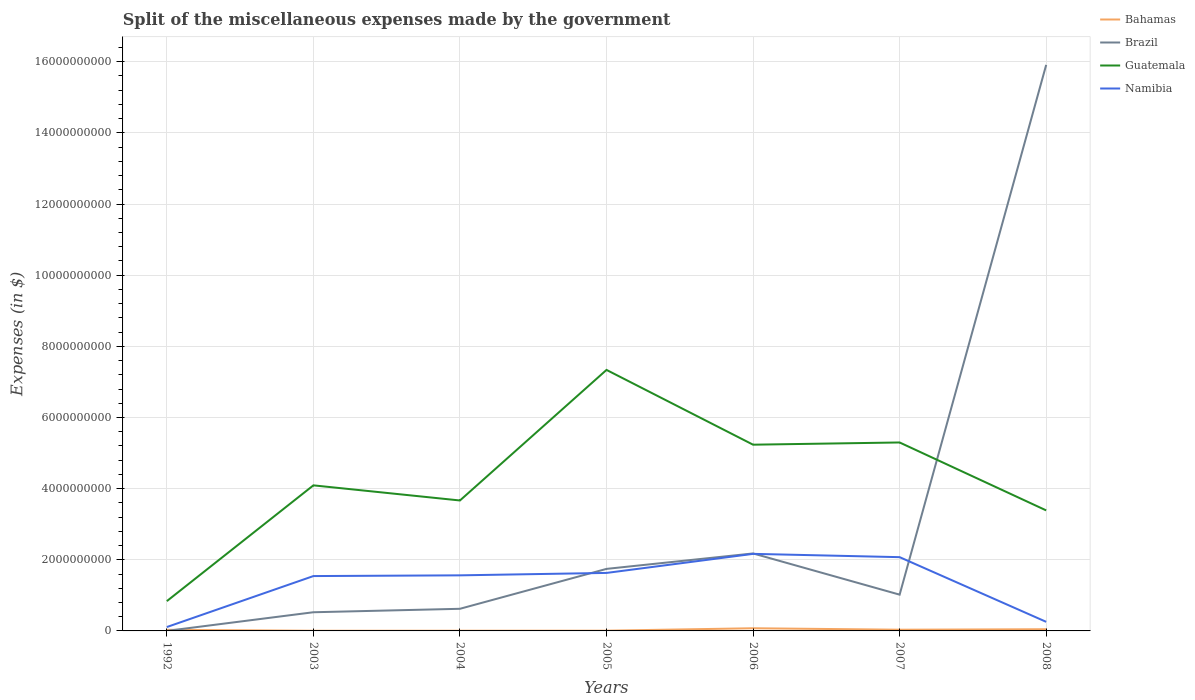How many different coloured lines are there?
Provide a succinct answer. 4. Does the line corresponding to Bahamas intersect with the line corresponding to Namibia?
Offer a terse response. No. Across all years, what is the maximum miscellaneous expenses made by the government in Bahamas?
Make the answer very short. 4.60e+06. In which year was the miscellaneous expenses made by the government in Guatemala maximum?
Your response must be concise. 1992. What is the total miscellaneous expenses made by the government in Bahamas in the graph?
Your answer should be compact. -9.39e+05. What is the difference between the highest and the second highest miscellaneous expenses made by the government in Namibia?
Provide a succinct answer. 2.06e+09. Is the miscellaneous expenses made by the government in Bahamas strictly greater than the miscellaneous expenses made by the government in Brazil over the years?
Provide a short and direct response. No. What is the difference between two consecutive major ticks on the Y-axis?
Make the answer very short. 2.00e+09. Are the values on the major ticks of Y-axis written in scientific E-notation?
Make the answer very short. No. Does the graph contain any zero values?
Make the answer very short. No. Does the graph contain grids?
Ensure brevity in your answer.  Yes. Where does the legend appear in the graph?
Your response must be concise. Top right. How many legend labels are there?
Ensure brevity in your answer.  4. What is the title of the graph?
Offer a very short reply. Split of the miscellaneous expenses made by the government. What is the label or title of the X-axis?
Your response must be concise. Years. What is the label or title of the Y-axis?
Offer a very short reply. Expenses (in $). What is the Expenses (in $) of Bahamas in 1992?
Make the answer very short. 3.16e+07. What is the Expenses (in $) in Brazil in 1992?
Keep it short and to the point. 1.12e+06. What is the Expenses (in $) of Guatemala in 1992?
Your answer should be compact. 8.37e+08. What is the Expenses (in $) in Namibia in 1992?
Offer a very short reply. 1.09e+08. What is the Expenses (in $) of Bahamas in 2003?
Provide a short and direct response. 4.60e+06. What is the Expenses (in $) in Brazil in 2003?
Your answer should be very brief. 5.25e+08. What is the Expenses (in $) in Guatemala in 2003?
Ensure brevity in your answer.  4.09e+09. What is the Expenses (in $) in Namibia in 2003?
Provide a short and direct response. 1.54e+09. What is the Expenses (in $) of Bahamas in 2004?
Ensure brevity in your answer.  5.54e+06. What is the Expenses (in $) in Brazil in 2004?
Provide a succinct answer. 6.22e+08. What is the Expenses (in $) of Guatemala in 2004?
Provide a succinct answer. 3.67e+09. What is the Expenses (in $) of Namibia in 2004?
Offer a terse response. 1.56e+09. What is the Expenses (in $) in Bahamas in 2005?
Your answer should be compact. 7.18e+06. What is the Expenses (in $) in Brazil in 2005?
Keep it short and to the point. 1.74e+09. What is the Expenses (in $) of Guatemala in 2005?
Ensure brevity in your answer.  7.34e+09. What is the Expenses (in $) in Namibia in 2005?
Offer a very short reply. 1.63e+09. What is the Expenses (in $) of Bahamas in 2006?
Ensure brevity in your answer.  7.53e+07. What is the Expenses (in $) of Brazil in 2006?
Offer a very short reply. 2.18e+09. What is the Expenses (in $) in Guatemala in 2006?
Provide a succinct answer. 5.24e+09. What is the Expenses (in $) of Namibia in 2006?
Offer a terse response. 2.17e+09. What is the Expenses (in $) in Bahamas in 2007?
Keep it short and to the point. 3.39e+07. What is the Expenses (in $) in Brazil in 2007?
Ensure brevity in your answer.  1.02e+09. What is the Expenses (in $) in Guatemala in 2007?
Keep it short and to the point. 5.30e+09. What is the Expenses (in $) of Namibia in 2007?
Keep it short and to the point. 2.07e+09. What is the Expenses (in $) of Bahamas in 2008?
Your answer should be very brief. 4.76e+07. What is the Expenses (in $) in Brazil in 2008?
Offer a terse response. 1.59e+1. What is the Expenses (in $) in Guatemala in 2008?
Offer a terse response. 3.39e+09. What is the Expenses (in $) in Namibia in 2008?
Give a very brief answer. 2.55e+08. Across all years, what is the maximum Expenses (in $) in Bahamas?
Your response must be concise. 7.53e+07. Across all years, what is the maximum Expenses (in $) in Brazil?
Your answer should be compact. 1.59e+1. Across all years, what is the maximum Expenses (in $) in Guatemala?
Make the answer very short. 7.34e+09. Across all years, what is the maximum Expenses (in $) in Namibia?
Make the answer very short. 2.17e+09. Across all years, what is the minimum Expenses (in $) of Bahamas?
Provide a succinct answer. 4.60e+06. Across all years, what is the minimum Expenses (in $) of Brazil?
Your answer should be compact. 1.12e+06. Across all years, what is the minimum Expenses (in $) of Guatemala?
Provide a succinct answer. 8.37e+08. Across all years, what is the minimum Expenses (in $) of Namibia?
Ensure brevity in your answer.  1.09e+08. What is the total Expenses (in $) in Bahamas in the graph?
Make the answer very short. 2.06e+08. What is the total Expenses (in $) of Brazil in the graph?
Your response must be concise. 2.20e+1. What is the total Expenses (in $) in Guatemala in the graph?
Give a very brief answer. 2.99e+1. What is the total Expenses (in $) of Namibia in the graph?
Make the answer very short. 9.34e+09. What is the difference between the Expenses (in $) of Bahamas in 1992 and that in 2003?
Give a very brief answer. 2.70e+07. What is the difference between the Expenses (in $) of Brazil in 1992 and that in 2003?
Make the answer very short. -5.24e+08. What is the difference between the Expenses (in $) of Guatemala in 1992 and that in 2003?
Offer a terse response. -3.25e+09. What is the difference between the Expenses (in $) of Namibia in 1992 and that in 2003?
Keep it short and to the point. -1.43e+09. What is the difference between the Expenses (in $) of Bahamas in 1992 and that in 2004?
Your response must be concise. 2.61e+07. What is the difference between the Expenses (in $) in Brazil in 1992 and that in 2004?
Keep it short and to the point. -6.21e+08. What is the difference between the Expenses (in $) in Guatemala in 1992 and that in 2004?
Provide a succinct answer. -2.83e+09. What is the difference between the Expenses (in $) in Namibia in 1992 and that in 2004?
Provide a succinct answer. -1.45e+09. What is the difference between the Expenses (in $) in Bahamas in 1992 and that in 2005?
Make the answer very short. 2.44e+07. What is the difference between the Expenses (in $) of Brazil in 1992 and that in 2005?
Provide a succinct answer. -1.74e+09. What is the difference between the Expenses (in $) of Guatemala in 1992 and that in 2005?
Offer a terse response. -6.50e+09. What is the difference between the Expenses (in $) of Namibia in 1992 and that in 2005?
Your answer should be very brief. -1.52e+09. What is the difference between the Expenses (in $) of Bahamas in 1992 and that in 2006?
Make the answer very short. -4.37e+07. What is the difference between the Expenses (in $) in Brazil in 1992 and that in 2006?
Your answer should be very brief. -2.18e+09. What is the difference between the Expenses (in $) of Guatemala in 1992 and that in 2006?
Offer a very short reply. -4.40e+09. What is the difference between the Expenses (in $) in Namibia in 1992 and that in 2006?
Make the answer very short. -2.06e+09. What is the difference between the Expenses (in $) of Bahamas in 1992 and that in 2007?
Make the answer very short. -2.30e+06. What is the difference between the Expenses (in $) of Brazil in 1992 and that in 2007?
Offer a very short reply. -1.02e+09. What is the difference between the Expenses (in $) in Guatemala in 1992 and that in 2007?
Ensure brevity in your answer.  -4.46e+09. What is the difference between the Expenses (in $) in Namibia in 1992 and that in 2007?
Give a very brief answer. -1.96e+09. What is the difference between the Expenses (in $) in Bahamas in 1992 and that in 2008?
Keep it short and to the point. -1.60e+07. What is the difference between the Expenses (in $) of Brazil in 1992 and that in 2008?
Offer a very short reply. -1.59e+1. What is the difference between the Expenses (in $) of Guatemala in 1992 and that in 2008?
Ensure brevity in your answer.  -2.55e+09. What is the difference between the Expenses (in $) in Namibia in 1992 and that in 2008?
Offer a terse response. -1.46e+08. What is the difference between the Expenses (in $) of Bahamas in 2003 and that in 2004?
Your answer should be compact. -9.39e+05. What is the difference between the Expenses (in $) in Brazil in 2003 and that in 2004?
Offer a terse response. -9.71e+07. What is the difference between the Expenses (in $) in Guatemala in 2003 and that in 2004?
Provide a short and direct response. 4.25e+08. What is the difference between the Expenses (in $) in Namibia in 2003 and that in 2004?
Your answer should be very brief. -2.04e+07. What is the difference between the Expenses (in $) in Bahamas in 2003 and that in 2005?
Make the answer very short. -2.58e+06. What is the difference between the Expenses (in $) in Brazil in 2003 and that in 2005?
Your response must be concise. -1.22e+09. What is the difference between the Expenses (in $) in Guatemala in 2003 and that in 2005?
Provide a succinct answer. -3.24e+09. What is the difference between the Expenses (in $) of Namibia in 2003 and that in 2005?
Your answer should be compact. -8.84e+07. What is the difference between the Expenses (in $) of Bahamas in 2003 and that in 2006?
Ensure brevity in your answer.  -7.07e+07. What is the difference between the Expenses (in $) of Brazil in 2003 and that in 2006?
Offer a very short reply. -1.65e+09. What is the difference between the Expenses (in $) in Guatemala in 2003 and that in 2006?
Give a very brief answer. -1.14e+09. What is the difference between the Expenses (in $) of Namibia in 2003 and that in 2006?
Provide a short and direct response. -6.24e+08. What is the difference between the Expenses (in $) in Bahamas in 2003 and that in 2007?
Keep it short and to the point. -2.93e+07. What is the difference between the Expenses (in $) in Brazil in 2003 and that in 2007?
Give a very brief answer. -4.94e+08. What is the difference between the Expenses (in $) in Guatemala in 2003 and that in 2007?
Give a very brief answer. -1.21e+09. What is the difference between the Expenses (in $) of Namibia in 2003 and that in 2007?
Provide a succinct answer. -5.32e+08. What is the difference between the Expenses (in $) of Bahamas in 2003 and that in 2008?
Keep it short and to the point. -4.30e+07. What is the difference between the Expenses (in $) in Brazil in 2003 and that in 2008?
Offer a very short reply. -1.54e+1. What is the difference between the Expenses (in $) in Guatemala in 2003 and that in 2008?
Provide a succinct answer. 7.04e+08. What is the difference between the Expenses (in $) of Namibia in 2003 and that in 2008?
Your answer should be very brief. 1.29e+09. What is the difference between the Expenses (in $) of Bahamas in 2004 and that in 2005?
Your response must be concise. -1.64e+06. What is the difference between the Expenses (in $) of Brazil in 2004 and that in 2005?
Give a very brief answer. -1.12e+09. What is the difference between the Expenses (in $) in Guatemala in 2004 and that in 2005?
Provide a succinct answer. -3.67e+09. What is the difference between the Expenses (in $) of Namibia in 2004 and that in 2005?
Make the answer very short. -6.80e+07. What is the difference between the Expenses (in $) in Bahamas in 2004 and that in 2006?
Offer a very short reply. -6.98e+07. What is the difference between the Expenses (in $) in Brazil in 2004 and that in 2006?
Your answer should be compact. -1.56e+09. What is the difference between the Expenses (in $) of Guatemala in 2004 and that in 2006?
Keep it short and to the point. -1.57e+09. What is the difference between the Expenses (in $) of Namibia in 2004 and that in 2006?
Your answer should be very brief. -6.04e+08. What is the difference between the Expenses (in $) in Bahamas in 2004 and that in 2007?
Ensure brevity in your answer.  -2.84e+07. What is the difference between the Expenses (in $) in Brazil in 2004 and that in 2007?
Provide a succinct answer. -3.97e+08. What is the difference between the Expenses (in $) in Guatemala in 2004 and that in 2007?
Give a very brief answer. -1.63e+09. What is the difference between the Expenses (in $) of Namibia in 2004 and that in 2007?
Provide a short and direct response. -5.11e+08. What is the difference between the Expenses (in $) in Bahamas in 2004 and that in 2008?
Make the answer very short. -4.21e+07. What is the difference between the Expenses (in $) in Brazil in 2004 and that in 2008?
Offer a terse response. -1.53e+1. What is the difference between the Expenses (in $) of Guatemala in 2004 and that in 2008?
Provide a succinct answer. 2.79e+08. What is the difference between the Expenses (in $) in Namibia in 2004 and that in 2008?
Give a very brief answer. 1.31e+09. What is the difference between the Expenses (in $) of Bahamas in 2005 and that in 2006?
Your answer should be very brief. -6.81e+07. What is the difference between the Expenses (in $) of Brazil in 2005 and that in 2006?
Give a very brief answer. -4.34e+08. What is the difference between the Expenses (in $) in Guatemala in 2005 and that in 2006?
Provide a succinct answer. 2.10e+09. What is the difference between the Expenses (in $) of Namibia in 2005 and that in 2006?
Your answer should be compact. -5.36e+08. What is the difference between the Expenses (in $) of Bahamas in 2005 and that in 2007?
Provide a succinct answer. -2.67e+07. What is the difference between the Expenses (in $) of Brazil in 2005 and that in 2007?
Offer a terse response. 7.24e+08. What is the difference between the Expenses (in $) of Guatemala in 2005 and that in 2007?
Keep it short and to the point. 2.04e+09. What is the difference between the Expenses (in $) in Namibia in 2005 and that in 2007?
Ensure brevity in your answer.  -4.43e+08. What is the difference between the Expenses (in $) in Bahamas in 2005 and that in 2008?
Offer a terse response. -4.04e+07. What is the difference between the Expenses (in $) in Brazil in 2005 and that in 2008?
Ensure brevity in your answer.  -1.42e+1. What is the difference between the Expenses (in $) in Guatemala in 2005 and that in 2008?
Give a very brief answer. 3.95e+09. What is the difference between the Expenses (in $) of Namibia in 2005 and that in 2008?
Offer a terse response. 1.37e+09. What is the difference between the Expenses (in $) in Bahamas in 2006 and that in 2007?
Ensure brevity in your answer.  4.14e+07. What is the difference between the Expenses (in $) of Brazil in 2006 and that in 2007?
Keep it short and to the point. 1.16e+09. What is the difference between the Expenses (in $) in Guatemala in 2006 and that in 2007?
Offer a terse response. -6.21e+07. What is the difference between the Expenses (in $) in Namibia in 2006 and that in 2007?
Your answer should be very brief. 9.26e+07. What is the difference between the Expenses (in $) in Bahamas in 2006 and that in 2008?
Provide a succinct answer. 2.77e+07. What is the difference between the Expenses (in $) in Brazil in 2006 and that in 2008?
Your answer should be very brief. -1.37e+1. What is the difference between the Expenses (in $) in Guatemala in 2006 and that in 2008?
Offer a terse response. 1.85e+09. What is the difference between the Expenses (in $) in Namibia in 2006 and that in 2008?
Make the answer very short. 1.91e+09. What is the difference between the Expenses (in $) of Bahamas in 2007 and that in 2008?
Make the answer very short. -1.37e+07. What is the difference between the Expenses (in $) of Brazil in 2007 and that in 2008?
Keep it short and to the point. -1.49e+1. What is the difference between the Expenses (in $) in Guatemala in 2007 and that in 2008?
Offer a very short reply. 1.91e+09. What is the difference between the Expenses (in $) in Namibia in 2007 and that in 2008?
Your answer should be very brief. 1.82e+09. What is the difference between the Expenses (in $) of Bahamas in 1992 and the Expenses (in $) of Brazil in 2003?
Offer a terse response. -4.93e+08. What is the difference between the Expenses (in $) of Bahamas in 1992 and the Expenses (in $) of Guatemala in 2003?
Your answer should be compact. -4.06e+09. What is the difference between the Expenses (in $) of Bahamas in 1992 and the Expenses (in $) of Namibia in 2003?
Provide a short and direct response. -1.51e+09. What is the difference between the Expenses (in $) in Brazil in 1992 and the Expenses (in $) in Guatemala in 2003?
Make the answer very short. -4.09e+09. What is the difference between the Expenses (in $) of Brazil in 1992 and the Expenses (in $) of Namibia in 2003?
Keep it short and to the point. -1.54e+09. What is the difference between the Expenses (in $) of Guatemala in 1992 and the Expenses (in $) of Namibia in 2003?
Provide a succinct answer. -7.05e+08. What is the difference between the Expenses (in $) of Bahamas in 1992 and the Expenses (in $) of Brazil in 2004?
Make the answer very short. -5.90e+08. What is the difference between the Expenses (in $) of Bahamas in 1992 and the Expenses (in $) of Guatemala in 2004?
Give a very brief answer. -3.64e+09. What is the difference between the Expenses (in $) in Bahamas in 1992 and the Expenses (in $) in Namibia in 2004?
Make the answer very short. -1.53e+09. What is the difference between the Expenses (in $) of Brazil in 1992 and the Expenses (in $) of Guatemala in 2004?
Offer a terse response. -3.67e+09. What is the difference between the Expenses (in $) in Brazil in 1992 and the Expenses (in $) in Namibia in 2004?
Offer a very short reply. -1.56e+09. What is the difference between the Expenses (in $) of Guatemala in 1992 and the Expenses (in $) of Namibia in 2004?
Your response must be concise. -7.25e+08. What is the difference between the Expenses (in $) in Bahamas in 1992 and the Expenses (in $) in Brazil in 2005?
Your response must be concise. -1.71e+09. What is the difference between the Expenses (in $) of Bahamas in 1992 and the Expenses (in $) of Guatemala in 2005?
Provide a short and direct response. -7.31e+09. What is the difference between the Expenses (in $) of Bahamas in 1992 and the Expenses (in $) of Namibia in 2005?
Offer a terse response. -1.60e+09. What is the difference between the Expenses (in $) of Brazil in 1992 and the Expenses (in $) of Guatemala in 2005?
Your response must be concise. -7.34e+09. What is the difference between the Expenses (in $) of Brazil in 1992 and the Expenses (in $) of Namibia in 2005?
Provide a short and direct response. -1.63e+09. What is the difference between the Expenses (in $) of Guatemala in 1992 and the Expenses (in $) of Namibia in 2005?
Provide a succinct answer. -7.93e+08. What is the difference between the Expenses (in $) in Bahamas in 1992 and the Expenses (in $) in Brazil in 2006?
Offer a terse response. -2.15e+09. What is the difference between the Expenses (in $) of Bahamas in 1992 and the Expenses (in $) of Guatemala in 2006?
Offer a very short reply. -5.20e+09. What is the difference between the Expenses (in $) in Bahamas in 1992 and the Expenses (in $) in Namibia in 2006?
Make the answer very short. -2.13e+09. What is the difference between the Expenses (in $) of Brazil in 1992 and the Expenses (in $) of Guatemala in 2006?
Your answer should be compact. -5.23e+09. What is the difference between the Expenses (in $) in Brazil in 1992 and the Expenses (in $) in Namibia in 2006?
Your answer should be compact. -2.16e+09. What is the difference between the Expenses (in $) in Guatemala in 1992 and the Expenses (in $) in Namibia in 2006?
Make the answer very short. -1.33e+09. What is the difference between the Expenses (in $) in Bahamas in 1992 and the Expenses (in $) in Brazil in 2007?
Your response must be concise. -9.88e+08. What is the difference between the Expenses (in $) of Bahamas in 1992 and the Expenses (in $) of Guatemala in 2007?
Make the answer very short. -5.27e+09. What is the difference between the Expenses (in $) of Bahamas in 1992 and the Expenses (in $) of Namibia in 2007?
Your answer should be compact. -2.04e+09. What is the difference between the Expenses (in $) in Brazil in 1992 and the Expenses (in $) in Guatemala in 2007?
Keep it short and to the point. -5.30e+09. What is the difference between the Expenses (in $) of Brazil in 1992 and the Expenses (in $) of Namibia in 2007?
Offer a terse response. -2.07e+09. What is the difference between the Expenses (in $) in Guatemala in 1992 and the Expenses (in $) in Namibia in 2007?
Make the answer very short. -1.24e+09. What is the difference between the Expenses (in $) of Bahamas in 1992 and the Expenses (in $) of Brazil in 2008?
Ensure brevity in your answer.  -1.59e+1. What is the difference between the Expenses (in $) of Bahamas in 1992 and the Expenses (in $) of Guatemala in 2008?
Your answer should be compact. -3.36e+09. What is the difference between the Expenses (in $) of Bahamas in 1992 and the Expenses (in $) of Namibia in 2008?
Your response must be concise. -2.24e+08. What is the difference between the Expenses (in $) in Brazil in 1992 and the Expenses (in $) in Guatemala in 2008?
Offer a terse response. -3.39e+09. What is the difference between the Expenses (in $) of Brazil in 1992 and the Expenses (in $) of Namibia in 2008?
Your answer should be very brief. -2.54e+08. What is the difference between the Expenses (in $) of Guatemala in 1992 and the Expenses (in $) of Namibia in 2008?
Your response must be concise. 5.82e+08. What is the difference between the Expenses (in $) of Bahamas in 2003 and the Expenses (in $) of Brazil in 2004?
Provide a succinct answer. -6.17e+08. What is the difference between the Expenses (in $) of Bahamas in 2003 and the Expenses (in $) of Guatemala in 2004?
Give a very brief answer. -3.66e+09. What is the difference between the Expenses (in $) in Bahamas in 2003 and the Expenses (in $) in Namibia in 2004?
Keep it short and to the point. -1.56e+09. What is the difference between the Expenses (in $) in Brazil in 2003 and the Expenses (in $) in Guatemala in 2004?
Give a very brief answer. -3.14e+09. What is the difference between the Expenses (in $) of Brazil in 2003 and the Expenses (in $) of Namibia in 2004?
Offer a terse response. -1.04e+09. What is the difference between the Expenses (in $) of Guatemala in 2003 and the Expenses (in $) of Namibia in 2004?
Provide a succinct answer. 2.53e+09. What is the difference between the Expenses (in $) in Bahamas in 2003 and the Expenses (in $) in Brazil in 2005?
Your answer should be compact. -1.74e+09. What is the difference between the Expenses (in $) of Bahamas in 2003 and the Expenses (in $) of Guatemala in 2005?
Keep it short and to the point. -7.33e+09. What is the difference between the Expenses (in $) of Bahamas in 2003 and the Expenses (in $) of Namibia in 2005?
Keep it short and to the point. -1.63e+09. What is the difference between the Expenses (in $) in Brazil in 2003 and the Expenses (in $) in Guatemala in 2005?
Your answer should be very brief. -6.81e+09. What is the difference between the Expenses (in $) of Brazil in 2003 and the Expenses (in $) of Namibia in 2005?
Your answer should be compact. -1.11e+09. What is the difference between the Expenses (in $) in Guatemala in 2003 and the Expenses (in $) in Namibia in 2005?
Give a very brief answer. 2.46e+09. What is the difference between the Expenses (in $) of Bahamas in 2003 and the Expenses (in $) of Brazil in 2006?
Make the answer very short. -2.17e+09. What is the difference between the Expenses (in $) in Bahamas in 2003 and the Expenses (in $) in Guatemala in 2006?
Make the answer very short. -5.23e+09. What is the difference between the Expenses (in $) of Bahamas in 2003 and the Expenses (in $) of Namibia in 2006?
Offer a terse response. -2.16e+09. What is the difference between the Expenses (in $) of Brazil in 2003 and the Expenses (in $) of Guatemala in 2006?
Offer a very short reply. -4.71e+09. What is the difference between the Expenses (in $) in Brazil in 2003 and the Expenses (in $) in Namibia in 2006?
Keep it short and to the point. -1.64e+09. What is the difference between the Expenses (in $) of Guatemala in 2003 and the Expenses (in $) of Namibia in 2006?
Your answer should be very brief. 1.93e+09. What is the difference between the Expenses (in $) in Bahamas in 2003 and the Expenses (in $) in Brazil in 2007?
Ensure brevity in your answer.  -1.01e+09. What is the difference between the Expenses (in $) in Bahamas in 2003 and the Expenses (in $) in Guatemala in 2007?
Keep it short and to the point. -5.29e+09. What is the difference between the Expenses (in $) of Bahamas in 2003 and the Expenses (in $) of Namibia in 2007?
Give a very brief answer. -2.07e+09. What is the difference between the Expenses (in $) in Brazil in 2003 and the Expenses (in $) in Guatemala in 2007?
Provide a short and direct response. -4.77e+09. What is the difference between the Expenses (in $) in Brazil in 2003 and the Expenses (in $) in Namibia in 2007?
Offer a very short reply. -1.55e+09. What is the difference between the Expenses (in $) of Guatemala in 2003 and the Expenses (in $) of Namibia in 2007?
Offer a very short reply. 2.02e+09. What is the difference between the Expenses (in $) of Bahamas in 2003 and the Expenses (in $) of Brazil in 2008?
Offer a very short reply. -1.59e+1. What is the difference between the Expenses (in $) in Bahamas in 2003 and the Expenses (in $) in Guatemala in 2008?
Your response must be concise. -3.38e+09. What is the difference between the Expenses (in $) in Bahamas in 2003 and the Expenses (in $) in Namibia in 2008?
Give a very brief answer. -2.51e+08. What is the difference between the Expenses (in $) of Brazil in 2003 and the Expenses (in $) of Guatemala in 2008?
Your answer should be compact. -2.86e+09. What is the difference between the Expenses (in $) of Brazil in 2003 and the Expenses (in $) of Namibia in 2008?
Offer a very short reply. 2.70e+08. What is the difference between the Expenses (in $) in Guatemala in 2003 and the Expenses (in $) in Namibia in 2008?
Offer a very short reply. 3.84e+09. What is the difference between the Expenses (in $) of Bahamas in 2004 and the Expenses (in $) of Brazil in 2005?
Offer a terse response. -1.74e+09. What is the difference between the Expenses (in $) in Bahamas in 2004 and the Expenses (in $) in Guatemala in 2005?
Provide a succinct answer. -7.33e+09. What is the difference between the Expenses (in $) in Bahamas in 2004 and the Expenses (in $) in Namibia in 2005?
Give a very brief answer. -1.62e+09. What is the difference between the Expenses (in $) of Brazil in 2004 and the Expenses (in $) of Guatemala in 2005?
Offer a very short reply. -6.71e+09. What is the difference between the Expenses (in $) in Brazil in 2004 and the Expenses (in $) in Namibia in 2005?
Offer a terse response. -1.01e+09. What is the difference between the Expenses (in $) in Guatemala in 2004 and the Expenses (in $) in Namibia in 2005?
Your answer should be compact. 2.04e+09. What is the difference between the Expenses (in $) of Bahamas in 2004 and the Expenses (in $) of Brazil in 2006?
Offer a very short reply. -2.17e+09. What is the difference between the Expenses (in $) in Bahamas in 2004 and the Expenses (in $) in Guatemala in 2006?
Offer a terse response. -5.23e+09. What is the difference between the Expenses (in $) in Bahamas in 2004 and the Expenses (in $) in Namibia in 2006?
Keep it short and to the point. -2.16e+09. What is the difference between the Expenses (in $) in Brazil in 2004 and the Expenses (in $) in Guatemala in 2006?
Provide a short and direct response. -4.61e+09. What is the difference between the Expenses (in $) of Brazil in 2004 and the Expenses (in $) of Namibia in 2006?
Give a very brief answer. -1.54e+09. What is the difference between the Expenses (in $) in Guatemala in 2004 and the Expenses (in $) in Namibia in 2006?
Provide a succinct answer. 1.50e+09. What is the difference between the Expenses (in $) of Bahamas in 2004 and the Expenses (in $) of Brazil in 2007?
Make the answer very short. -1.01e+09. What is the difference between the Expenses (in $) in Bahamas in 2004 and the Expenses (in $) in Guatemala in 2007?
Your answer should be very brief. -5.29e+09. What is the difference between the Expenses (in $) of Bahamas in 2004 and the Expenses (in $) of Namibia in 2007?
Your response must be concise. -2.07e+09. What is the difference between the Expenses (in $) in Brazil in 2004 and the Expenses (in $) in Guatemala in 2007?
Keep it short and to the point. -4.68e+09. What is the difference between the Expenses (in $) of Brazil in 2004 and the Expenses (in $) of Namibia in 2007?
Give a very brief answer. -1.45e+09. What is the difference between the Expenses (in $) of Guatemala in 2004 and the Expenses (in $) of Namibia in 2007?
Your answer should be compact. 1.59e+09. What is the difference between the Expenses (in $) in Bahamas in 2004 and the Expenses (in $) in Brazil in 2008?
Provide a short and direct response. -1.59e+1. What is the difference between the Expenses (in $) of Bahamas in 2004 and the Expenses (in $) of Guatemala in 2008?
Your response must be concise. -3.38e+09. What is the difference between the Expenses (in $) of Bahamas in 2004 and the Expenses (in $) of Namibia in 2008?
Keep it short and to the point. -2.50e+08. What is the difference between the Expenses (in $) of Brazil in 2004 and the Expenses (in $) of Guatemala in 2008?
Your answer should be compact. -2.77e+09. What is the difference between the Expenses (in $) of Brazil in 2004 and the Expenses (in $) of Namibia in 2008?
Your answer should be compact. 3.67e+08. What is the difference between the Expenses (in $) in Guatemala in 2004 and the Expenses (in $) in Namibia in 2008?
Give a very brief answer. 3.41e+09. What is the difference between the Expenses (in $) of Bahamas in 2005 and the Expenses (in $) of Brazil in 2006?
Offer a terse response. -2.17e+09. What is the difference between the Expenses (in $) of Bahamas in 2005 and the Expenses (in $) of Guatemala in 2006?
Offer a very short reply. -5.23e+09. What is the difference between the Expenses (in $) of Bahamas in 2005 and the Expenses (in $) of Namibia in 2006?
Offer a very short reply. -2.16e+09. What is the difference between the Expenses (in $) in Brazil in 2005 and the Expenses (in $) in Guatemala in 2006?
Give a very brief answer. -3.49e+09. What is the difference between the Expenses (in $) of Brazil in 2005 and the Expenses (in $) of Namibia in 2006?
Your answer should be very brief. -4.22e+08. What is the difference between the Expenses (in $) of Guatemala in 2005 and the Expenses (in $) of Namibia in 2006?
Provide a succinct answer. 5.17e+09. What is the difference between the Expenses (in $) of Bahamas in 2005 and the Expenses (in $) of Brazil in 2007?
Give a very brief answer. -1.01e+09. What is the difference between the Expenses (in $) in Bahamas in 2005 and the Expenses (in $) in Guatemala in 2007?
Keep it short and to the point. -5.29e+09. What is the difference between the Expenses (in $) of Bahamas in 2005 and the Expenses (in $) of Namibia in 2007?
Give a very brief answer. -2.07e+09. What is the difference between the Expenses (in $) of Brazil in 2005 and the Expenses (in $) of Guatemala in 2007?
Provide a short and direct response. -3.55e+09. What is the difference between the Expenses (in $) in Brazil in 2005 and the Expenses (in $) in Namibia in 2007?
Keep it short and to the point. -3.30e+08. What is the difference between the Expenses (in $) in Guatemala in 2005 and the Expenses (in $) in Namibia in 2007?
Your answer should be very brief. 5.26e+09. What is the difference between the Expenses (in $) in Bahamas in 2005 and the Expenses (in $) in Brazil in 2008?
Provide a short and direct response. -1.59e+1. What is the difference between the Expenses (in $) of Bahamas in 2005 and the Expenses (in $) of Guatemala in 2008?
Your answer should be very brief. -3.38e+09. What is the difference between the Expenses (in $) in Bahamas in 2005 and the Expenses (in $) in Namibia in 2008?
Your answer should be very brief. -2.48e+08. What is the difference between the Expenses (in $) of Brazil in 2005 and the Expenses (in $) of Guatemala in 2008?
Your answer should be very brief. -1.64e+09. What is the difference between the Expenses (in $) in Brazil in 2005 and the Expenses (in $) in Namibia in 2008?
Ensure brevity in your answer.  1.49e+09. What is the difference between the Expenses (in $) of Guatemala in 2005 and the Expenses (in $) of Namibia in 2008?
Offer a terse response. 7.08e+09. What is the difference between the Expenses (in $) of Bahamas in 2006 and the Expenses (in $) of Brazil in 2007?
Provide a short and direct response. -9.44e+08. What is the difference between the Expenses (in $) in Bahamas in 2006 and the Expenses (in $) in Guatemala in 2007?
Your answer should be compact. -5.22e+09. What is the difference between the Expenses (in $) in Bahamas in 2006 and the Expenses (in $) in Namibia in 2007?
Keep it short and to the point. -2.00e+09. What is the difference between the Expenses (in $) in Brazil in 2006 and the Expenses (in $) in Guatemala in 2007?
Provide a short and direct response. -3.12e+09. What is the difference between the Expenses (in $) in Brazil in 2006 and the Expenses (in $) in Namibia in 2007?
Make the answer very short. 1.04e+08. What is the difference between the Expenses (in $) in Guatemala in 2006 and the Expenses (in $) in Namibia in 2007?
Make the answer very short. 3.16e+09. What is the difference between the Expenses (in $) of Bahamas in 2006 and the Expenses (in $) of Brazil in 2008?
Provide a short and direct response. -1.58e+1. What is the difference between the Expenses (in $) in Bahamas in 2006 and the Expenses (in $) in Guatemala in 2008?
Your answer should be compact. -3.31e+09. What is the difference between the Expenses (in $) of Bahamas in 2006 and the Expenses (in $) of Namibia in 2008?
Ensure brevity in your answer.  -1.80e+08. What is the difference between the Expenses (in $) in Brazil in 2006 and the Expenses (in $) in Guatemala in 2008?
Your response must be concise. -1.21e+09. What is the difference between the Expenses (in $) of Brazil in 2006 and the Expenses (in $) of Namibia in 2008?
Provide a succinct answer. 1.92e+09. What is the difference between the Expenses (in $) of Guatemala in 2006 and the Expenses (in $) of Namibia in 2008?
Give a very brief answer. 4.98e+09. What is the difference between the Expenses (in $) in Bahamas in 2007 and the Expenses (in $) in Brazil in 2008?
Offer a terse response. -1.59e+1. What is the difference between the Expenses (in $) of Bahamas in 2007 and the Expenses (in $) of Guatemala in 2008?
Provide a short and direct response. -3.35e+09. What is the difference between the Expenses (in $) of Bahamas in 2007 and the Expenses (in $) of Namibia in 2008?
Your answer should be compact. -2.22e+08. What is the difference between the Expenses (in $) of Brazil in 2007 and the Expenses (in $) of Guatemala in 2008?
Offer a terse response. -2.37e+09. What is the difference between the Expenses (in $) in Brazil in 2007 and the Expenses (in $) in Namibia in 2008?
Your answer should be compact. 7.64e+08. What is the difference between the Expenses (in $) of Guatemala in 2007 and the Expenses (in $) of Namibia in 2008?
Offer a very short reply. 5.04e+09. What is the average Expenses (in $) of Bahamas per year?
Make the answer very short. 2.94e+07. What is the average Expenses (in $) in Brazil per year?
Make the answer very short. 3.14e+09. What is the average Expenses (in $) in Guatemala per year?
Give a very brief answer. 4.26e+09. What is the average Expenses (in $) of Namibia per year?
Provide a succinct answer. 1.33e+09. In the year 1992, what is the difference between the Expenses (in $) of Bahamas and Expenses (in $) of Brazil?
Keep it short and to the point. 3.05e+07. In the year 1992, what is the difference between the Expenses (in $) of Bahamas and Expenses (in $) of Guatemala?
Your answer should be compact. -8.06e+08. In the year 1992, what is the difference between the Expenses (in $) in Bahamas and Expenses (in $) in Namibia?
Offer a terse response. -7.77e+07. In the year 1992, what is the difference between the Expenses (in $) of Brazil and Expenses (in $) of Guatemala?
Offer a very short reply. -8.36e+08. In the year 1992, what is the difference between the Expenses (in $) in Brazil and Expenses (in $) in Namibia?
Offer a terse response. -1.08e+08. In the year 1992, what is the difference between the Expenses (in $) in Guatemala and Expenses (in $) in Namibia?
Give a very brief answer. 7.28e+08. In the year 2003, what is the difference between the Expenses (in $) of Bahamas and Expenses (in $) of Brazil?
Make the answer very short. -5.20e+08. In the year 2003, what is the difference between the Expenses (in $) in Bahamas and Expenses (in $) in Guatemala?
Ensure brevity in your answer.  -4.09e+09. In the year 2003, what is the difference between the Expenses (in $) in Bahamas and Expenses (in $) in Namibia?
Offer a terse response. -1.54e+09. In the year 2003, what is the difference between the Expenses (in $) of Brazil and Expenses (in $) of Guatemala?
Provide a short and direct response. -3.57e+09. In the year 2003, what is the difference between the Expenses (in $) in Brazil and Expenses (in $) in Namibia?
Provide a succinct answer. -1.02e+09. In the year 2003, what is the difference between the Expenses (in $) of Guatemala and Expenses (in $) of Namibia?
Make the answer very short. 2.55e+09. In the year 2004, what is the difference between the Expenses (in $) of Bahamas and Expenses (in $) of Brazil?
Your response must be concise. -6.17e+08. In the year 2004, what is the difference between the Expenses (in $) of Bahamas and Expenses (in $) of Guatemala?
Ensure brevity in your answer.  -3.66e+09. In the year 2004, what is the difference between the Expenses (in $) in Bahamas and Expenses (in $) in Namibia?
Provide a short and direct response. -1.56e+09. In the year 2004, what is the difference between the Expenses (in $) in Brazil and Expenses (in $) in Guatemala?
Your response must be concise. -3.04e+09. In the year 2004, what is the difference between the Expenses (in $) of Brazil and Expenses (in $) of Namibia?
Your answer should be very brief. -9.40e+08. In the year 2004, what is the difference between the Expenses (in $) of Guatemala and Expenses (in $) of Namibia?
Offer a very short reply. 2.10e+09. In the year 2005, what is the difference between the Expenses (in $) in Bahamas and Expenses (in $) in Brazil?
Your answer should be very brief. -1.74e+09. In the year 2005, what is the difference between the Expenses (in $) in Bahamas and Expenses (in $) in Guatemala?
Offer a terse response. -7.33e+09. In the year 2005, what is the difference between the Expenses (in $) in Bahamas and Expenses (in $) in Namibia?
Provide a succinct answer. -1.62e+09. In the year 2005, what is the difference between the Expenses (in $) in Brazil and Expenses (in $) in Guatemala?
Your answer should be compact. -5.59e+09. In the year 2005, what is the difference between the Expenses (in $) of Brazil and Expenses (in $) of Namibia?
Ensure brevity in your answer.  1.14e+08. In the year 2005, what is the difference between the Expenses (in $) in Guatemala and Expenses (in $) in Namibia?
Make the answer very short. 5.71e+09. In the year 2006, what is the difference between the Expenses (in $) in Bahamas and Expenses (in $) in Brazil?
Provide a succinct answer. -2.10e+09. In the year 2006, what is the difference between the Expenses (in $) of Bahamas and Expenses (in $) of Guatemala?
Provide a short and direct response. -5.16e+09. In the year 2006, what is the difference between the Expenses (in $) in Bahamas and Expenses (in $) in Namibia?
Give a very brief answer. -2.09e+09. In the year 2006, what is the difference between the Expenses (in $) in Brazil and Expenses (in $) in Guatemala?
Give a very brief answer. -3.06e+09. In the year 2006, what is the difference between the Expenses (in $) in Brazil and Expenses (in $) in Namibia?
Your response must be concise. 1.18e+07. In the year 2006, what is the difference between the Expenses (in $) of Guatemala and Expenses (in $) of Namibia?
Provide a succinct answer. 3.07e+09. In the year 2007, what is the difference between the Expenses (in $) in Bahamas and Expenses (in $) in Brazil?
Offer a terse response. -9.86e+08. In the year 2007, what is the difference between the Expenses (in $) in Bahamas and Expenses (in $) in Guatemala?
Your response must be concise. -5.26e+09. In the year 2007, what is the difference between the Expenses (in $) in Bahamas and Expenses (in $) in Namibia?
Provide a succinct answer. -2.04e+09. In the year 2007, what is the difference between the Expenses (in $) in Brazil and Expenses (in $) in Guatemala?
Provide a succinct answer. -4.28e+09. In the year 2007, what is the difference between the Expenses (in $) of Brazil and Expenses (in $) of Namibia?
Ensure brevity in your answer.  -1.05e+09. In the year 2007, what is the difference between the Expenses (in $) in Guatemala and Expenses (in $) in Namibia?
Offer a very short reply. 3.22e+09. In the year 2008, what is the difference between the Expenses (in $) in Bahamas and Expenses (in $) in Brazil?
Provide a short and direct response. -1.59e+1. In the year 2008, what is the difference between the Expenses (in $) of Bahamas and Expenses (in $) of Guatemala?
Your answer should be very brief. -3.34e+09. In the year 2008, what is the difference between the Expenses (in $) of Bahamas and Expenses (in $) of Namibia?
Your response must be concise. -2.08e+08. In the year 2008, what is the difference between the Expenses (in $) of Brazil and Expenses (in $) of Guatemala?
Give a very brief answer. 1.25e+1. In the year 2008, what is the difference between the Expenses (in $) of Brazil and Expenses (in $) of Namibia?
Your response must be concise. 1.57e+1. In the year 2008, what is the difference between the Expenses (in $) in Guatemala and Expenses (in $) in Namibia?
Provide a succinct answer. 3.13e+09. What is the ratio of the Expenses (in $) in Bahamas in 1992 to that in 2003?
Give a very brief answer. 6.87. What is the ratio of the Expenses (in $) in Brazil in 1992 to that in 2003?
Provide a short and direct response. 0. What is the ratio of the Expenses (in $) in Guatemala in 1992 to that in 2003?
Make the answer very short. 0.2. What is the ratio of the Expenses (in $) in Namibia in 1992 to that in 2003?
Your answer should be very brief. 0.07. What is the ratio of the Expenses (in $) of Bahamas in 1992 to that in 2004?
Provide a succinct answer. 5.71. What is the ratio of the Expenses (in $) of Brazil in 1992 to that in 2004?
Your answer should be compact. 0. What is the ratio of the Expenses (in $) of Guatemala in 1992 to that in 2004?
Give a very brief answer. 0.23. What is the ratio of the Expenses (in $) of Namibia in 1992 to that in 2004?
Your answer should be compact. 0.07. What is the ratio of the Expenses (in $) in Bahamas in 1992 to that in 2005?
Ensure brevity in your answer.  4.4. What is the ratio of the Expenses (in $) of Brazil in 1992 to that in 2005?
Ensure brevity in your answer.  0. What is the ratio of the Expenses (in $) in Guatemala in 1992 to that in 2005?
Keep it short and to the point. 0.11. What is the ratio of the Expenses (in $) in Namibia in 1992 to that in 2005?
Give a very brief answer. 0.07. What is the ratio of the Expenses (in $) of Bahamas in 1992 to that in 2006?
Make the answer very short. 0.42. What is the ratio of the Expenses (in $) in Brazil in 1992 to that in 2006?
Your answer should be compact. 0. What is the ratio of the Expenses (in $) in Guatemala in 1992 to that in 2006?
Keep it short and to the point. 0.16. What is the ratio of the Expenses (in $) of Namibia in 1992 to that in 2006?
Your answer should be very brief. 0.05. What is the ratio of the Expenses (in $) in Bahamas in 1992 to that in 2007?
Your answer should be very brief. 0.93. What is the ratio of the Expenses (in $) in Brazil in 1992 to that in 2007?
Give a very brief answer. 0. What is the ratio of the Expenses (in $) in Guatemala in 1992 to that in 2007?
Provide a short and direct response. 0.16. What is the ratio of the Expenses (in $) in Namibia in 1992 to that in 2007?
Provide a succinct answer. 0.05. What is the ratio of the Expenses (in $) in Bahamas in 1992 to that in 2008?
Your answer should be compact. 0.66. What is the ratio of the Expenses (in $) of Brazil in 1992 to that in 2008?
Ensure brevity in your answer.  0. What is the ratio of the Expenses (in $) in Guatemala in 1992 to that in 2008?
Ensure brevity in your answer.  0.25. What is the ratio of the Expenses (in $) of Namibia in 1992 to that in 2008?
Give a very brief answer. 0.43. What is the ratio of the Expenses (in $) of Bahamas in 2003 to that in 2004?
Provide a short and direct response. 0.83. What is the ratio of the Expenses (in $) in Brazil in 2003 to that in 2004?
Make the answer very short. 0.84. What is the ratio of the Expenses (in $) in Guatemala in 2003 to that in 2004?
Provide a succinct answer. 1.12. What is the ratio of the Expenses (in $) in Namibia in 2003 to that in 2004?
Keep it short and to the point. 0.99. What is the ratio of the Expenses (in $) of Bahamas in 2003 to that in 2005?
Provide a succinct answer. 0.64. What is the ratio of the Expenses (in $) in Brazil in 2003 to that in 2005?
Your answer should be compact. 0.3. What is the ratio of the Expenses (in $) of Guatemala in 2003 to that in 2005?
Your answer should be compact. 0.56. What is the ratio of the Expenses (in $) in Namibia in 2003 to that in 2005?
Your answer should be compact. 0.95. What is the ratio of the Expenses (in $) of Bahamas in 2003 to that in 2006?
Provide a short and direct response. 0.06. What is the ratio of the Expenses (in $) in Brazil in 2003 to that in 2006?
Provide a succinct answer. 0.24. What is the ratio of the Expenses (in $) of Guatemala in 2003 to that in 2006?
Offer a terse response. 0.78. What is the ratio of the Expenses (in $) of Namibia in 2003 to that in 2006?
Your answer should be very brief. 0.71. What is the ratio of the Expenses (in $) in Bahamas in 2003 to that in 2007?
Your answer should be very brief. 0.14. What is the ratio of the Expenses (in $) of Brazil in 2003 to that in 2007?
Ensure brevity in your answer.  0.52. What is the ratio of the Expenses (in $) in Guatemala in 2003 to that in 2007?
Your answer should be very brief. 0.77. What is the ratio of the Expenses (in $) in Namibia in 2003 to that in 2007?
Keep it short and to the point. 0.74. What is the ratio of the Expenses (in $) in Bahamas in 2003 to that in 2008?
Your answer should be very brief. 0.1. What is the ratio of the Expenses (in $) of Brazil in 2003 to that in 2008?
Your answer should be very brief. 0.03. What is the ratio of the Expenses (in $) of Guatemala in 2003 to that in 2008?
Your answer should be very brief. 1.21. What is the ratio of the Expenses (in $) of Namibia in 2003 to that in 2008?
Provide a short and direct response. 6.04. What is the ratio of the Expenses (in $) of Bahamas in 2004 to that in 2005?
Make the answer very short. 0.77. What is the ratio of the Expenses (in $) of Brazil in 2004 to that in 2005?
Give a very brief answer. 0.36. What is the ratio of the Expenses (in $) in Guatemala in 2004 to that in 2005?
Keep it short and to the point. 0.5. What is the ratio of the Expenses (in $) of Bahamas in 2004 to that in 2006?
Your answer should be compact. 0.07. What is the ratio of the Expenses (in $) of Brazil in 2004 to that in 2006?
Your response must be concise. 0.29. What is the ratio of the Expenses (in $) of Guatemala in 2004 to that in 2006?
Provide a short and direct response. 0.7. What is the ratio of the Expenses (in $) of Namibia in 2004 to that in 2006?
Your response must be concise. 0.72. What is the ratio of the Expenses (in $) of Bahamas in 2004 to that in 2007?
Your answer should be compact. 0.16. What is the ratio of the Expenses (in $) of Brazil in 2004 to that in 2007?
Offer a very short reply. 0.61. What is the ratio of the Expenses (in $) in Guatemala in 2004 to that in 2007?
Your answer should be very brief. 0.69. What is the ratio of the Expenses (in $) of Namibia in 2004 to that in 2007?
Provide a short and direct response. 0.75. What is the ratio of the Expenses (in $) of Bahamas in 2004 to that in 2008?
Offer a very short reply. 0.12. What is the ratio of the Expenses (in $) of Brazil in 2004 to that in 2008?
Keep it short and to the point. 0.04. What is the ratio of the Expenses (in $) of Guatemala in 2004 to that in 2008?
Ensure brevity in your answer.  1.08. What is the ratio of the Expenses (in $) in Namibia in 2004 to that in 2008?
Your answer should be very brief. 6.12. What is the ratio of the Expenses (in $) of Bahamas in 2005 to that in 2006?
Offer a very short reply. 0.1. What is the ratio of the Expenses (in $) of Brazil in 2005 to that in 2006?
Provide a short and direct response. 0.8. What is the ratio of the Expenses (in $) of Guatemala in 2005 to that in 2006?
Your answer should be very brief. 1.4. What is the ratio of the Expenses (in $) in Namibia in 2005 to that in 2006?
Your response must be concise. 0.75. What is the ratio of the Expenses (in $) in Bahamas in 2005 to that in 2007?
Your response must be concise. 0.21. What is the ratio of the Expenses (in $) of Brazil in 2005 to that in 2007?
Keep it short and to the point. 1.71. What is the ratio of the Expenses (in $) in Guatemala in 2005 to that in 2007?
Provide a short and direct response. 1.39. What is the ratio of the Expenses (in $) in Namibia in 2005 to that in 2007?
Provide a short and direct response. 0.79. What is the ratio of the Expenses (in $) of Bahamas in 2005 to that in 2008?
Offer a terse response. 0.15. What is the ratio of the Expenses (in $) of Brazil in 2005 to that in 2008?
Make the answer very short. 0.11. What is the ratio of the Expenses (in $) of Guatemala in 2005 to that in 2008?
Provide a succinct answer. 2.17. What is the ratio of the Expenses (in $) of Namibia in 2005 to that in 2008?
Keep it short and to the point. 6.38. What is the ratio of the Expenses (in $) of Bahamas in 2006 to that in 2007?
Your answer should be very brief. 2.22. What is the ratio of the Expenses (in $) of Brazil in 2006 to that in 2007?
Make the answer very short. 2.14. What is the ratio of the Expenses (in $) in Guatemala in 2006 to that in 2007?
Provide a short and direct response. 0.99. What is the ratio of the Expenses (in $) in Namibia in 2006 to that in 2007?
Provide a short and direct response. 1.04. What is the ratio of the Expenses (in $) in Bahamas in 2006 to that in 2008?
Provide a short and direct response. 1.58. What is the ratio of the Expenses (in $) in Brazil in 2006 to that in 2008?
Offer a terse response. 0.14. What is the ratio of the Expenses (in $) of Guatemala in 2006 to that in 2008?
Ensure brevity in your answer.  1.55. What is the ratio of the Expenses (in $) in Namibia in 2006 to that in 2008?
Your answer should be very brief. 8.48. What is the ratio of the Expenses (in $) of Bahamas in 2007 to that in 2008?
Your answer should be very brief. 0.71. What is the ratio of the Expenses (in $) in Brazil in 2007 to that in 2008?
Provide a succinct answer. 0.06. What is the ratio of the Expenses (in $) of Guatemala in 2007 to that in 2008?
Your answer should be compact. 1.56. What is the ratio of the Expenses (in $) in Namibia in 2007 to that in 2008?
Offer a very short reply. 8.12. What is the difference between the highest and the second highest Expenses (in $) of Bahamas?
Your answer should be compact. 2.77e+07. What is the difference between the highest and the second highest Expenses (in $) of Brazil?
Your answer should be very brief. 1.37e+1. What is the difference between the highest and the second highest Expenses (in $) in Guatemala?
Offer a very short reply. 2.04e+09. What is the difference between the highest and the second highest Expenses (in $) in Namibia?
Provide a succinct answer. 9.26e+07. What is the difference between the highest and the lowest Expenses (in $) of Bahamas?
Make the answer very short. 7.07e+07. What is the difference between the highest and the lowest Expenses (in $) in Brazil?
Ensure brevity in your answer.  1.59e+1. What is the difference between the highest and the lowest Expenses (in $) of Guatemala?
Your answer should be compact. 6.50e+09. What is the difference between the highest and the lowest Expenses (in $) of Namibia?
Give a very brief answer. 2.06e+09. 